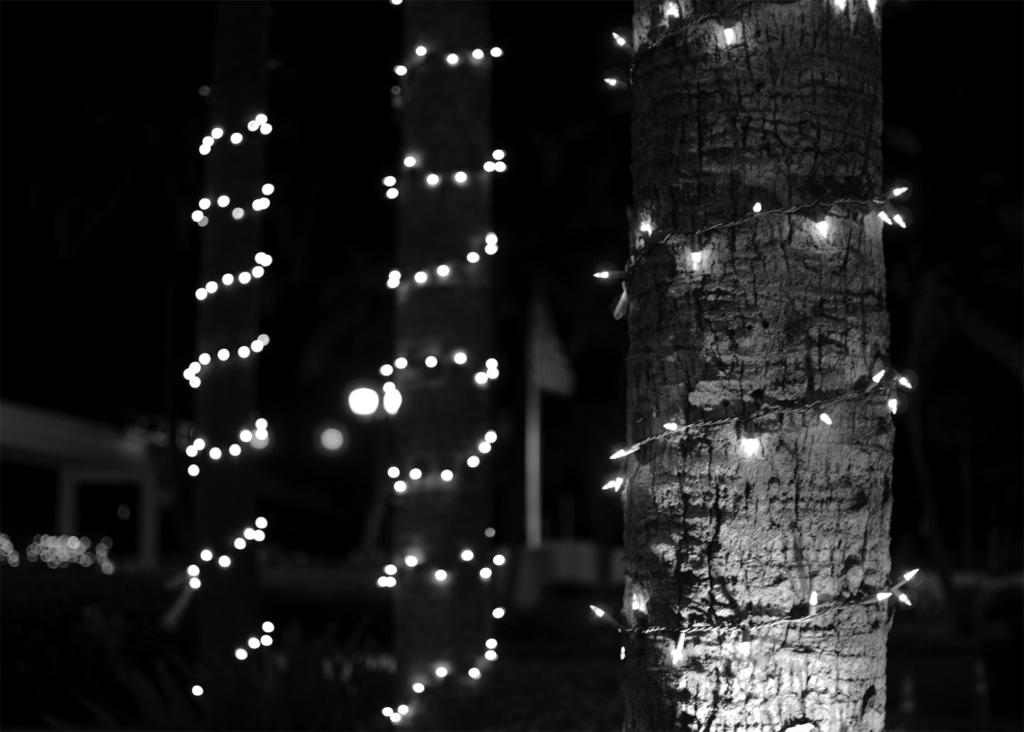What type of objects can be seen in the image? There are tree trunks in the image. What is unique about the appearance of the tree trunks? The tree trunks have decorative lights wrapped around them. Reasoning: Let's think step by identifying the main subjects in the image, which are the tree trunks. We then focus on a specific detail about their appearance, which is the presence of decorative lights. Each question is designed to elicit a specific detail about the image that is known from the provided facts. Absurd Question/Answer: What type of cherry is used to decorate the bushes in the image? There are no cherries or bushes present in the image. What type of quill is used to write on the tree trunks in the image? There are no quills or writing on the tree trunks in the image. 